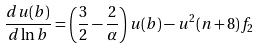<formula> <loc_0><loc_0><loc_500><loc_500>\frac { d u ( b ) } { d \ln b } = \left ( \frac { 3 } { 2 } - \frac { 2 } { \alpha } \right ) u ( b ) - u ^ { 2 } ( n + 8 ) f _ { 2 }</formula> 